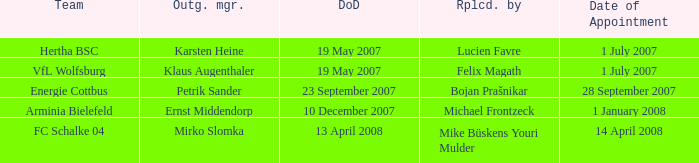When is the appointment date for outgoing manager Petrik Sander? 28 September 2007. 